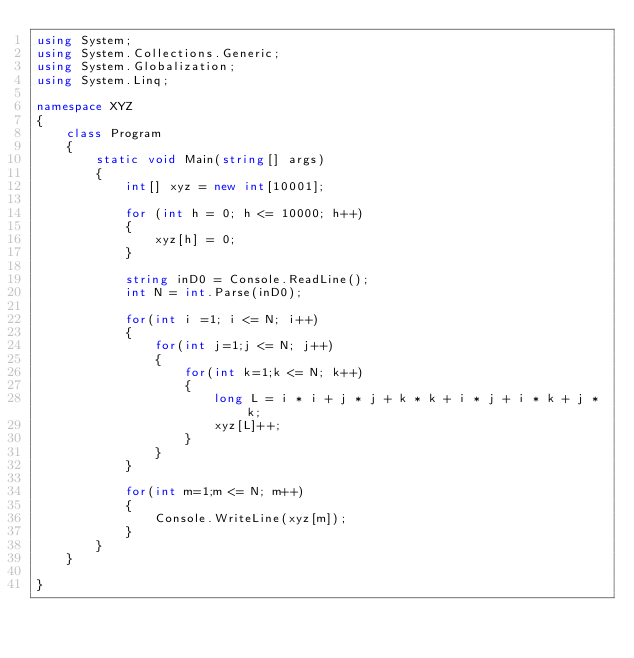<code> <loc_0><loc_0><loc_500><loc_500><_C#_>using System;
using System.Collections.Generic;
using System.Globalization;
using System.Linq;

namespace XYZ
{
    class Program
    {
        static void Main(string[] args)
        {
            int[] xyz = new int[10001];

            for (int h = 0; h <= 10000; h++)
            {
                xyz[h] = 0;
            }

            string inD0 = Console.ReadLine();
            int N = int.Parse(inD0);

            for(int i =1; i <= N; i++)
            {
                for(int j=1;j <= N; j++)
                {
                    for(int k=1;k <= N; k++)
                    {
                        long L = i * i + j * j + k * k + i * j + i * k + j * k;
                        xyz[L]++;
                    }
                }
            }

            for(int m=1;m <= N; m++)
            {
                Console.WriteLine(xyz[m]);
            }
        }
    }

}
</code> 